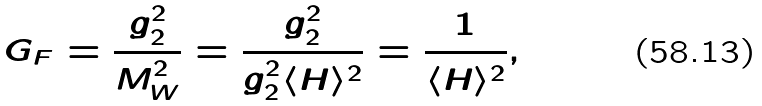Convert formula to latex. <formula><loc_0><loc_0><loc_500><loc_500>G _ { F } = \frac { g _ { 2 } ^ { 2 } } { M _ { W } ^ { 2 } } = \frac { g _ { 2 } ^ { 2 } } { g _ { 2 } ^ { 2 } \langle H \rangle ^ { 2 } } = \frac { 1 } { \langle H \rangle ^ { 2 } } ,</formula> 